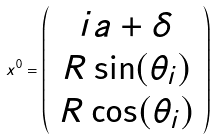Convert formula to latex. <formula><loc_0><loc_0><loc_500><loc_500>x ^ { 0 } = \left ( \begin{array} { c } i a + \delta \\ R \sin ( \theta _ { i } ) \\ R \cos ( \theta _ { i } ) \end{array} \right )</formula> 